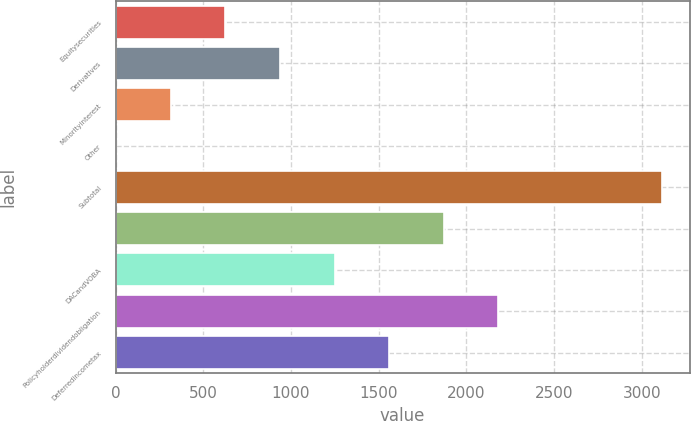Convert chart. <chart><loc_0><loc_0><loc_500><loc_500><bar_chart><fcel>Equitysecurities<fcel>Derivatives<fcel>Minorityinterest<fcel>Other<fcel>Subtotal<fcel>Unnamed: 5<fcel>DACandVOBA<fcel>Policyholderdividendobligation<fcel>Deferredincometax<nl><fcel>626<fcel>937.5<fcel>314.5<fcel>3<fcel>3118<fcel>1872<fcel>1249<fcel>2183.5<fcel>1560.5<nl></chart> 